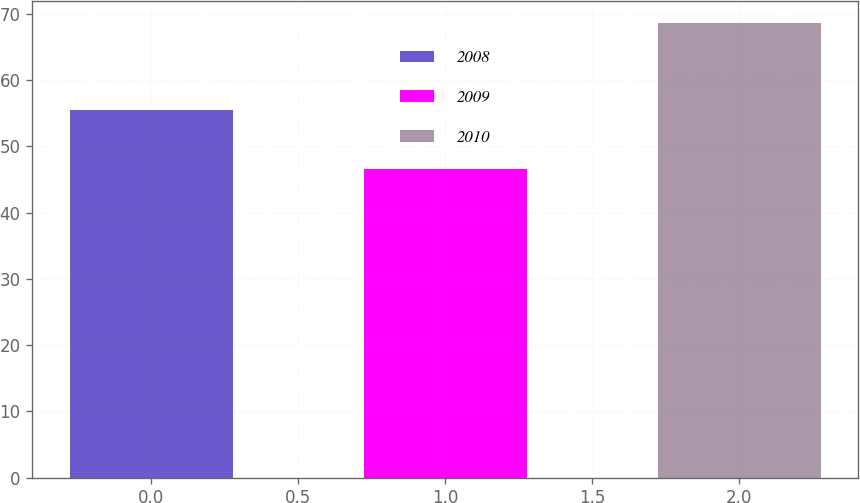<chart> <loc_0><loc_0><loc_500><loc_500><bar_chart><fcel>2008<fcel>2009<fcel>2010<nl><fcel>55.49<fcel>46.52<fcel>68.57<nl></chart> 